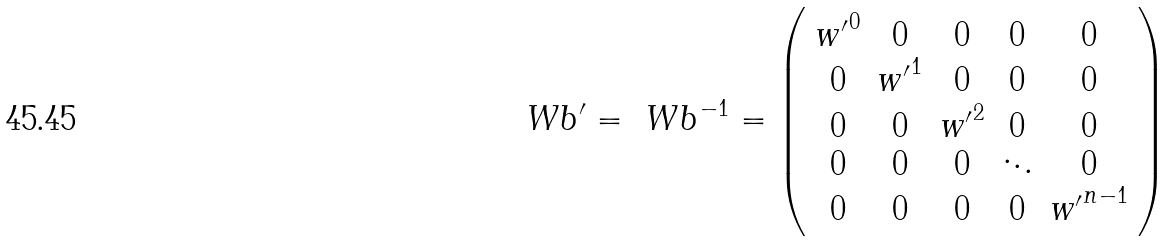Convert formula to latex. <formula><loc_0><loc_0><loc_500><loc_500>\ W b ^ { \prime } = \ W b ^ { - 1 } = \left ( \begin{array} { c c c c c } { w ^ { \prime } } ^ { 0 } & 0 & 0 & 0 & 0 \\ 0 & { w ^ { \prime } } ^ { 1 } & 0 & 0 & 0 \\ 0 & 0 & { w ^ { \prime } } ^ { 2 } & 0 & 0 \\ 0 & 0 & 0 & \ddots & 0 \\ 0 & 0 & 0 & 0 & { w ^ { \prime } } ^ { n - 1 } \end{array} \right ) \\</formula> 